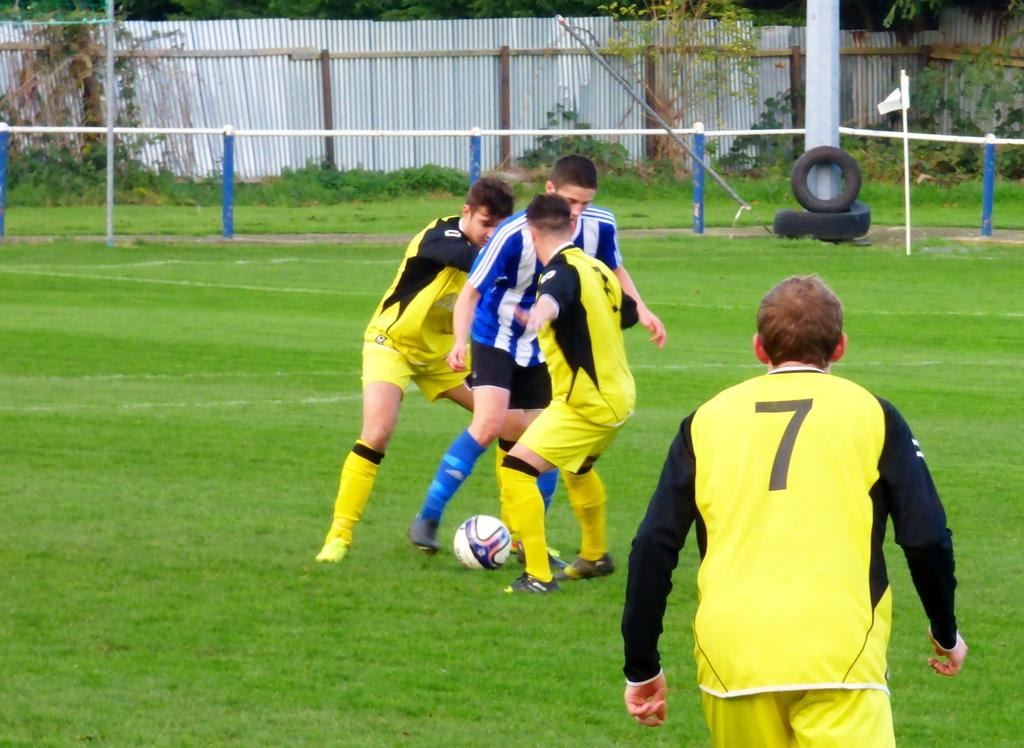What are the persons in the image doing? The persons in the image are playing on the ground. What can be seen in the background of the image? In the background of the image, there is a flag, tyres, a pole, trees, and fencing. What channel is the police requesting in the image? There is no police or channel present in the image. The image features persons playing on the ground and various background elements, but no reference to a police request or a channel. 